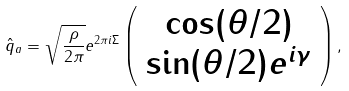Convert formula to latex. <formula><loc_0><loc_0><loc_500><loc_500>\hat { q } _ { a } = \sqrt { \frac { \rho } { 2 \pi } } e ^ { 2 \pi i \Sigma } \left ( \begin{array} { c } \cos ( \theta / 2 ) \\ \sin ( \theta / 2 ) e ^ { i \gamma } \end{array} \right ) ,</formula> 